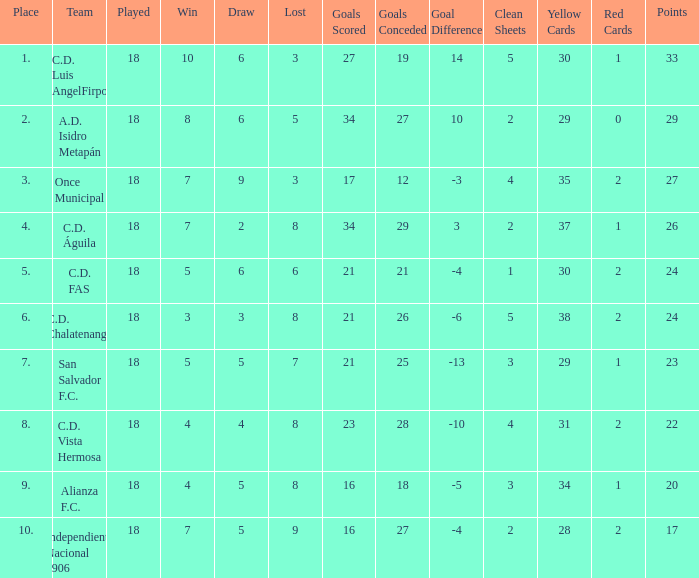What were the goal conceded that had a lost greater than 8 and more than 17 points? None. 